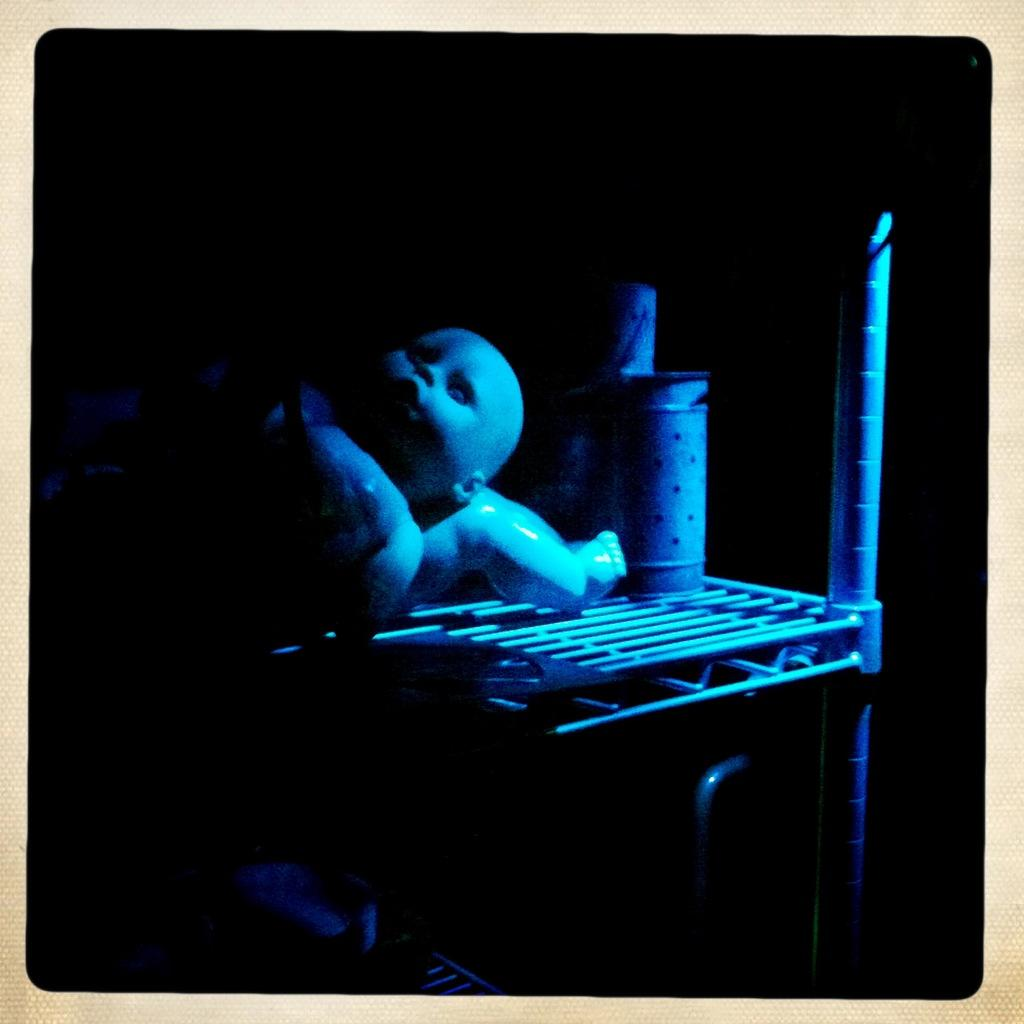What type of toy can be seen in the image? There is a toy that resembles a baby in the image. What piece of furniture is present in the image? There is a table in the image. What is placed on the table? There is an object on the table. How would you describe the lighting in the image? The background of the image is dark. What type of cushion is used to support the silk in the image? There is no cushion or silk present in the image. What word is written on the toy in the image? The toy does not have any words written on it; it is a toy that resembles a baby. 